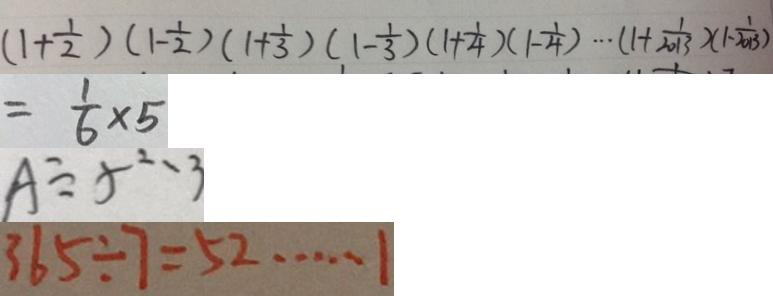Convert formula to latex. <formula><loc_0><loc_0><loc_500><loc_500>( 1 + \frac { 1 } { 2 } ) ( 1 - \frac { 1 } { 2 } ) ( 1 + \frac { 1 } { 3 } ) ( 1 - \frac { 1 } { 3 } ) ( 1 + \frac { 1 } { 4 } ) ( 1 - \frac { 1 } { 4 } ) \cdots ( 1 + \frac { 1 } { 2 0 1 3 } ) ( 1 - \frac { 1 } { 2 0 1 3 } ) 
 = \frac { 1 } { 6 } \times 5 
 A \div 5 \cdots 3 
 3 6 5 \div 7 = 5 2 \cdots 1</formula> 